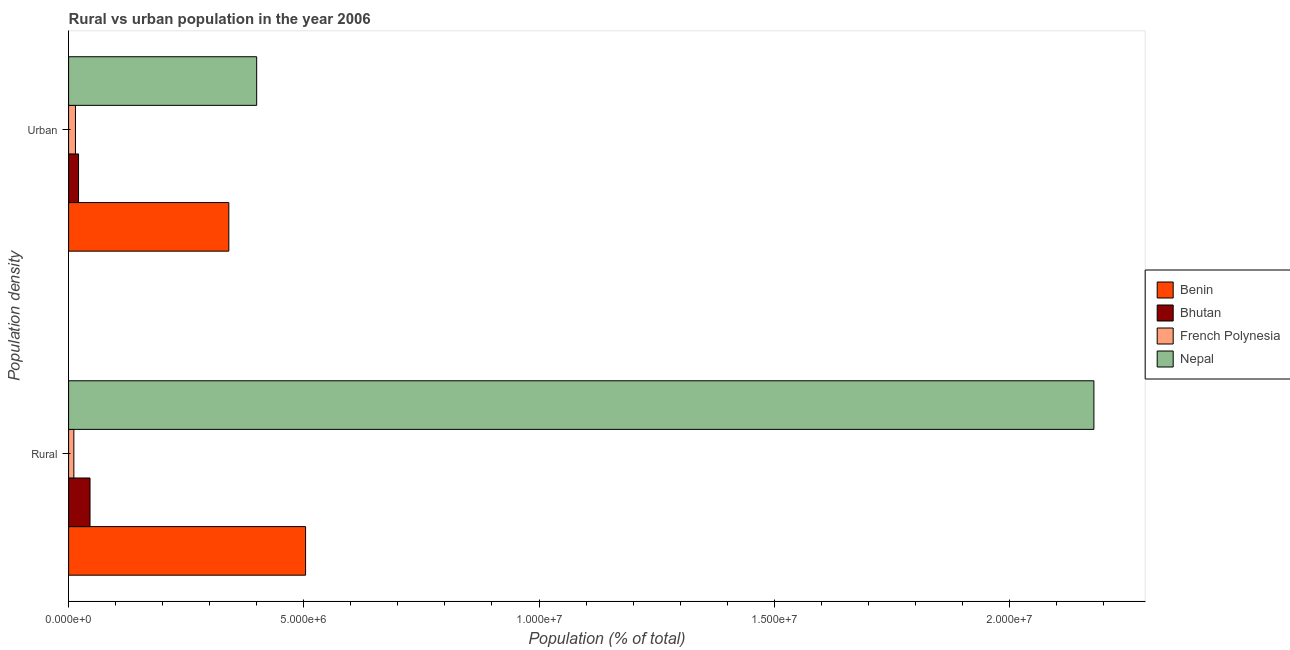How many groups of bars are there?
Offer a terse response. 2. Are the number of bars on each tick of the Y-axis equal?
Your response must be concise. Yes. What is the label of the 1st group of bars from the top?
Keep it short and to the point. Urban. What is the rural population density in Bhutan?
Ensure brevity in your answer.  4.55e+05. Across all countries, what is the maximum urban population density?
Provide a succinct answer. 4.00e+06. Across all countries, what is the minimum rural population density?
Your answer should be compact. 1.12e+05. In which country was the rural population density maximum?
Provide a short and direct response. Nepal. In which country was the urban population density minimum?
Provide a succinct answer. French Polynesia. What is the total rural population density in the graph?
Keep it short and to the point. 2.74e+07. What is the difference between the rural population density in Bhutan and that in Nepal?
Your answer should be very brief. -2.13e+07. What is the difference between the urban population density in Bhutan and the rural population density in Benin?
Offer a terse response. -4.83e+06. What is the average urban population density per country?
Ensure brevity in your answer.  1.94e+06. What is the difference between the urban population density and rural population density in Nepal?
Offer a terse response. -1.78e+07. What is the ratio of the urban population density in French Polynesia to that in Nepal?
Offer a terse response. 0.04. What does the 2nd bar from the top in Urban represents?
Keep it short and to the point. French Polynesia. What does the 2nd bar from the bottom in Urban represents?
Offer a very short reply. Bhutan. Are all the bars in the graph horizontal?
Your response must be concise. Yes. How many countries are there in the graph?
Ensure brevity in your answer.  4. What is the difference between two consecutive major ticks on the X-axis?
Provide a succinct answer. 5.00e+06. Are the values on the major ticks of X-axis written in scientific E-notation?
Make the answer very short. Yes. How many legend labels are there?
Offer a terse response. 4. What is the title of the graph?
Provide a succinct answer. Rural vs urban population in the year 2006. Does "Turkey" appear as one of the legend labels in the graph?
Offer a very short reply. No. What is the label or title of the X-axis?
Keep it short and to the point. Population (% of total). What is the label or title of the Y-axis?
Your answer should be compact. Population density. What is the Population (% of total) of Benin in Rural?
Provide a succinct answer. 5.04e+06. What is the Population (% of total) in Bhutan in Rural?
Provide a succinct answer. 4.55e+05. What is the Population (% of total) in French Polynesia in Rural?
Keep it short and to the point. 1.12e+05. What is the Population (% of total) of Nepal in Rural?
Keep it short and to the point. 2.18e+07. What is the Population (% of total) of Benin in Urban?
Keep it short and to the point. 3.41e+06. What is the Population (% of total) in Bhutan in Urban?
Provide a short and direct response. 2.11e+05. What is the Population (% of total) of French Polynesia in Urban?
Provide a short and direct response. 1.46e+05. What is the Population (% of total) of Nepal in Urban?
Your answer should be very brief. 4.00e+06. Across all Population density, what is the maximum Population (% of total) of Benin?
Your answer should be compact. 5.04e+06. Across all Population density, what is the maximum Population (% of total) of Bhutan?
Keep it short and to the point. 4.55e+05. Across all Population density, what is the maximum Population (% of total) of French Polynesia?
Your answer should be very brief. 1.46e+05. Across all Population density, what is the maximum Population (% of total) of Nepal?
Provide a succinct answer. 2.18e+07. Across all Population density, what is the minimum Population (% of total) in Benin?
Provide a succinct answer. 3.41e+06. Across all Population density, what is the minimum Population (% of total) in Bhutan?
Your answer should be compact. 2.11e+05. Across all Population density, what is the minimum Population (% of total) of French Polynesia?
Your answer should be compact. 1.12e+05. Across all Population density, what is the minimum Population (% of total) of Nepal?
Offer a terse response. 4.00e+06. What is the total Population (% of total) in Benin in the graph?
Ensure brevity in your answer.  8.44e+06. What is the total Population (% of total) of Bhutan in the graph?
Provide a succinct answer. 6.67e+05. What is the total Population (% of total) of French Polynesia in the graph?
Offer a terse response. 2.58e+05. What is the total Population (% of total) in Nepal in the graph?
Offer a very short reply. 2.58e+07. What is the difference between the Population (% of total) of Benin in Rural and that in Urban?
Make the answer very short. 1.63e+06. What is the difference between the Population (% of total) in Bhutan in Rural and that in Urban?
Provide a short and direct response. 2.44e+05. What is the difference between the Population (% of total) of French Polynesia in Rural and that in Urban?
Provide a succinct answer. -3.41e+04. What is the difference between the Population (% of total) in Nepal in Rural and that in Urban?
Make the answer very short. 1.78e+07. What is the difference between the Population (% of total) in Benin in Rural and the Population (% of total) in Bhutan in Urban?
Offer a terse response. 4.83e+06. What is the difference between the Population (% of total) of Benin in Rural and the Population (% of total) of French Polynesia in Urban?
Make the answer very short. 4.89e+06. What is the difference between the Population (% of total) of Benin in Rural and the Population (% of total) of Nepal in Urban?
Your response must be concise. 1.04e+06. What is the difference between the Population (% of total) in Bhutan in Rural and the Population (% of total) in French Polynesia in Urban?
Offer a very short reply. 3.09e+05. What is the difference between the Population (% of total) of Bhutan in Rural and the Population (% of total) of Nepal in Urban?
Provide a succinct answer. -3.54e+06. What is the difference between the Population (% of total) in French Polynesia in Rural and the Population (% of total) in Nepal in Urban?
Ensure brevity in your answer.  -3.89e+06. What is the average Population (% of total) in Benin per Population density?
Provide a short and direct response. 4.22e+06. What is the average Population (% of total) in Bhutan per Population density?
Your answer should be very brief. 3.33e+05. What is the average Population (% of total) in French Polynesia per Population density?
Offer a very short reply. 1.29e+05. What is the average Population (% of total) of Nepal per Population density?
Provide a short and direct response. 1.29e+07. What is the difference between the Population (% of total) of Benin and Population (% of total) of Bhutan in Rural?
Your response must be concise. 4.58e+06. What is the difference between the Population (% of total) in Benin and Population (% of total) in French Polynesia in Rural?
Your answer should be very brief. 4.93e+06. What is the difference between the Population (% of total) in Benin and Population (% of total) in Nepal in Rural?
Make the answer very short. -1.68e+07. What is the difference between the Population (% of total) of Bhutan and Population (% of total) of French Polynesia in Rural?
Offer a terse response. 3.44e+05. What is the difference between the Population (% of total) in Bhutan and Population (% of total) in Nepal in Rural?
Offer a terse response. -2.13e+07. What is the difference between the Population (% of total) in French Polynesia and Population (% of total) in Nepal in Rural?
Your response must be concise. -2.17e+07. What is the difference between the Population (% of total) of Benin and Population (% of total) of Bhutan in Urban?
Your answer should be very brief. 3.19e+06. What is the difference between the Population (% of total) of Benin and Population (% of total) of French Polynesia in Urban?
Provide a short and direct response. 3.26e+06. What is the difference between the Population (% of total) in Benin and Population (% of total) in Nepal in Urban?
Offer a very short reply. -5.92e+05. What is the difference between the Population (% of total) in Bhutan and Population (% of total) in French Polynesia in Urban?
Give a very brief answer. 6.56e+04. What is the difference between the Population (% of total) of Bhutan and Population (% of total) of Nepal in Urban?
Offer a very short reply. -3.79e+06. What is the difference between the Population (% of total) in French Polynesia and Population (% of total) in Nepal in Urban?
Offer a very short reply. -3.85e+06. What is the ratio of the Population (% of total) in Benin in Rural to that in Urban?
Your answer should be very brief. 1.48. What is the ratio of the Population (% of total) of Bhutan in Rural to that in Urban?
Provide a short and direct response. 2.15. What is the ratio of the Population (% of total) of French Polynesia in Rural to that in Urban?
Make the answer very short. 0.77. What is the ratio of the Population (% of total) in Nepal in Rural to that in Urban?
Your answer should be very brief. 5.45. What is the difference between the highest and the second highest Population (% of total) in Benin?
Your answer should be very brief. 1.63e+06. What is the difference between the highest and the second highest Population (% of total) in Bhutan?
Keep it short and to the point. 2.44e+05. What is the difference between the highest and the second highest Population (% of total) in French Polynesia?
Your answer should be compact. 3.41e+04. What is the difference between the highest and the second highest Population (% of total) in Nepal?
Provide a succinct answer. 1.78e+07. What is the difference between the highest and the lowest Population (% of total) of Benin?
Provide a short and direct response. 1.63e+06. What is the difference between the highest and the lowest Population (% of total) of Bhutan?
Provide a succinct answer. 2.44e+05. What is the difference between the highest and the lowest Population (% of total) of French Polynesia?
Offer a very short reply. 3.41e+04. What is the difference between the highest and the lowest Population (% of total) of Nepal?
Offer a very short reply. 1.78e+07. 